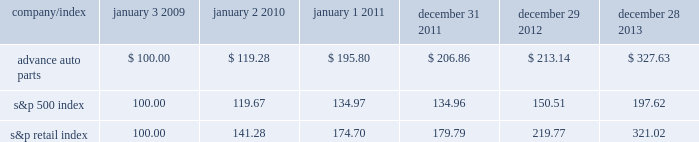Stock price performance the following graph shows a comparison of the cumulative total return on our common stock , the standard & poor 2019s 500 index and the standard & poor 2019s retail index .
The graph assumes that the value of an investment in our common stock and in each such index was $ 100 on january 3 , 2009 , and that any dividends have been reinvested .
The comparison in the graph below is based solely on historical data and is not intended to forecast the possible future performance of our common stock .
Comparison of cumulative total return among advance auto parts , inc. , s&p 500 index and s&p retail index company/index january 3 , january 2 , january 1 , december 31 , december 29 , december 28 .

What is the total return for every dollar invested in s&p500 index in january 2009 and sold in january 2011? 
Computations: (((134.97 - 100) / 100) * 1)
Answer: 0.3497. Stock price performance the following graph shows a comparison of the cumulative total return on our common stock , the standard & poor 2019s 500 index and the standard & poor 2019s retail index .
The graph assumes that the value of an investment in our common stock and in each such index was $ 100 on january 3 , 2009 , and that any dividends have been reinvested .
The comparison in the graph below is based solely on historical data and is not intended to forecast the possible future performance of our common stock .
Comparison of cumulative total return among advance auto parts , inc. , s&p 500 index and s&p retail index company/index january 3 , january 2 , january 1 , december 31 , december 29 , december 28 .

What is the total return for every dollar invested in advanced auto parts in january 2009 and sold in january 2011? 
Computations: (((195.80 - 100) / 100) * 1)
Answer: 0.958. 